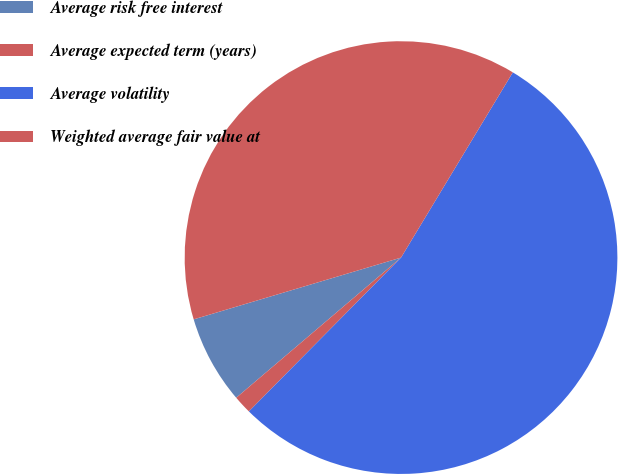Convert chart to OTSL. <chart><loc_0><loc_0><loc_500><loc_500><pie_chart><fcel>Average risk free interest<fcel>Average expected term (years)<fcel>Average volatility<fcel>Weighted average fair value at<nl><fcel>6.61%<fcel>1.37%<fcel>53.77%<fcel>38.25%<nl></chart> 